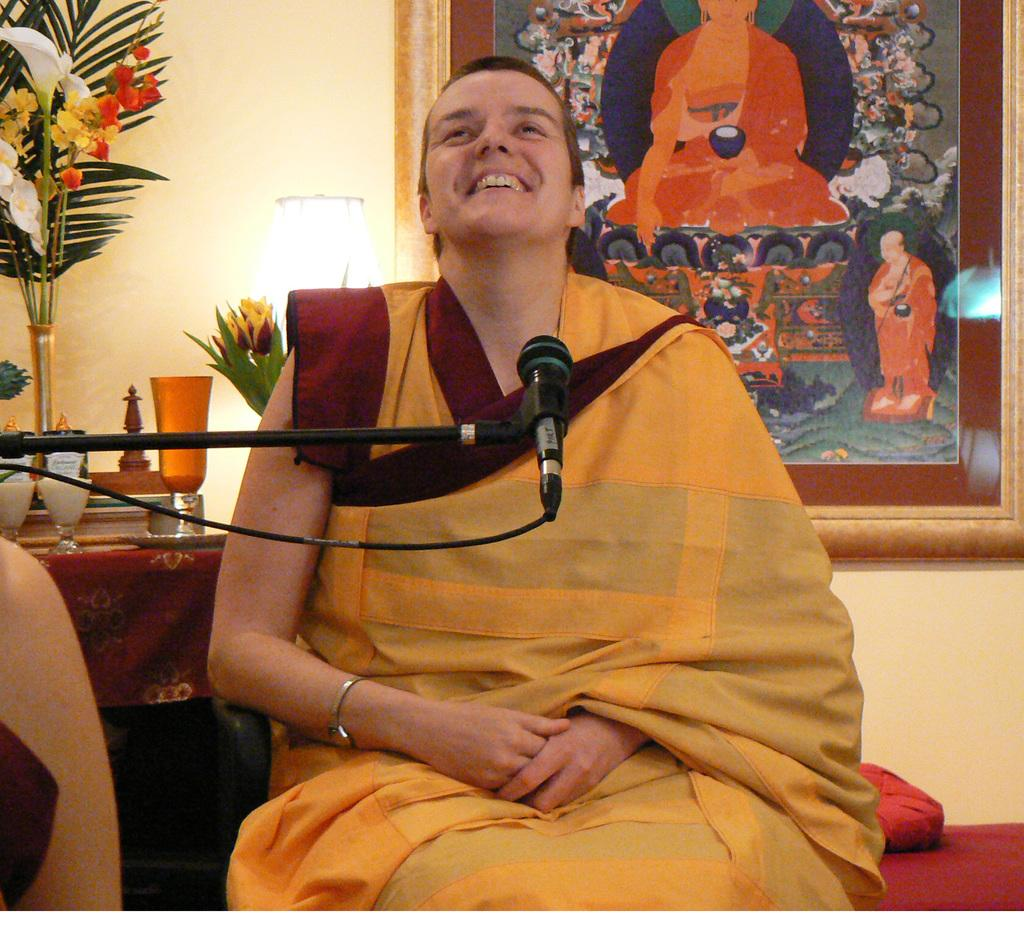Who or what is the main subject in the image? There is a person in the middle of the image. What is the person doing in the image? The person is in front of a mic. What can be seen in the background of the image? There is a photo frame on the wall in the background of the image. How many cows are visible in the image? There are no cows present in the image. What advice might the person's grandfather have given them before the event? The image does not provide any information about the person's grandfather or any advice they might have given. 